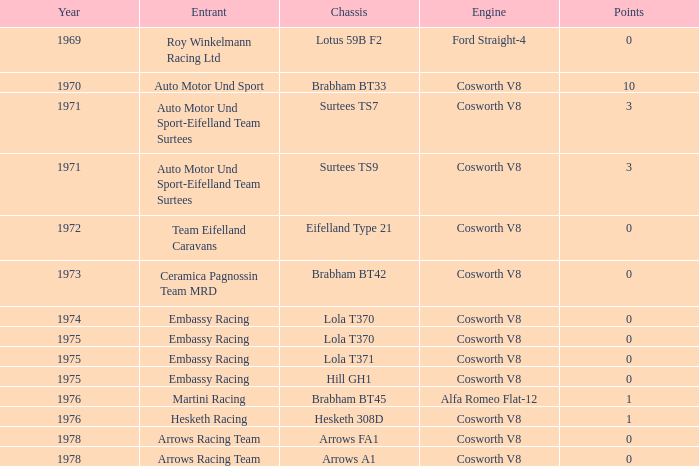What was the total amount of points in 1978 with a Chassis of arrows fa1? 0.0. 